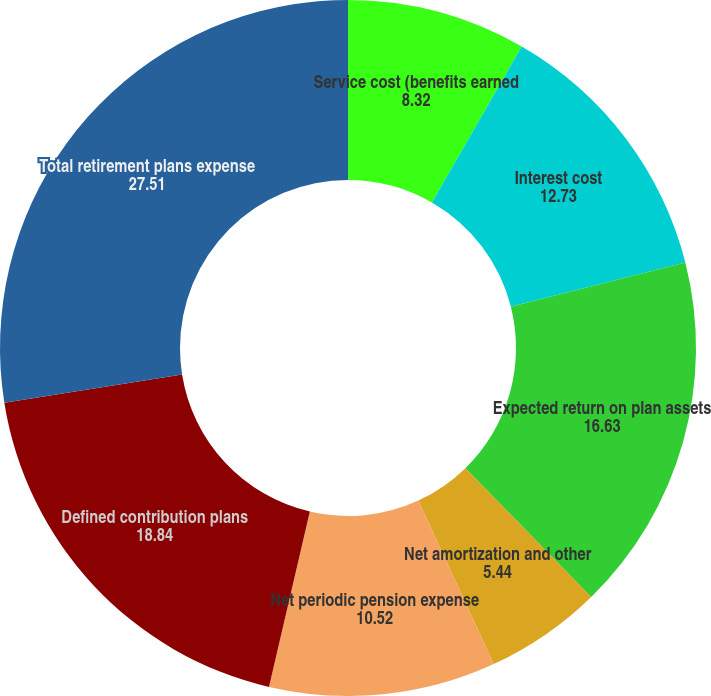<chart> <loc_0><loc_0><loc_500><loc_500><pie_chart><fcel>Service cost (benefits earned<fcel>Interest cost<fcel>Expected return on plan assets<fcel>Net amortization and other<fcel>Net periodic pension expense<fcel>Defined contribution plans<fcel>Total retirement plans expense<nl><fcel>8.32%<fcel>12.73%<fcel>16.63%<fcel>5.44%<fcel>10.52%<fcel>18.84%<fcel>27.51%<nl></chart> 